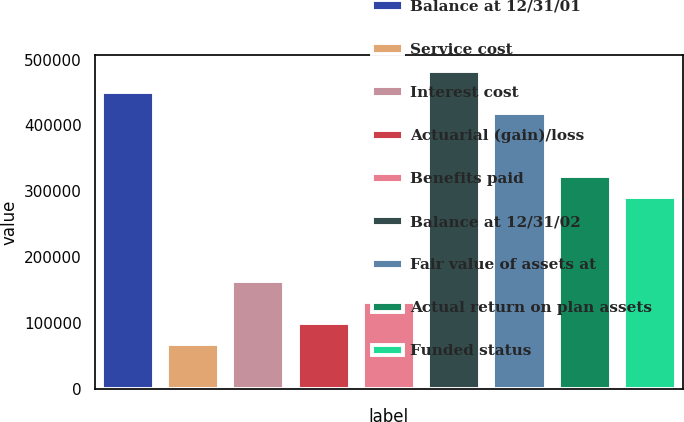<chart> <loc_0><loc_0><loc_500><loc_500><bar_chart><fcel>Balance at 12/31/01<fcel>Service cost<fcel>Interest cost<fcel>Actuarial (gain)/loss<fcel>Benefits paid<fcel>Balance at 12/31/02<fcel>Fair value of assets at<fcel>Actual return on plan assets<fcel>Funded status<nl><fcel>450828<fcel>69039.4<fcel>164486<fcel>100855<fcel>132671<fcel>482644<fcel>419012<fcel>323565<fcel>291749<nl></chart> 